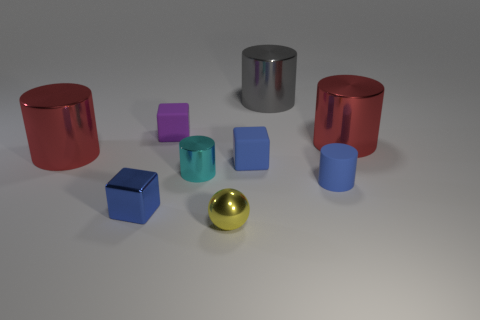Subtract all cyan metal cylinders. How many cylinders are left? 4 Add 1 cyan metal cylinders. How many objects exist? 10 Subtract 4 cylinders. How many cylinders are left? 1 Subtract all gray cylinders. How many cylinders are left? 4 Subtract all blocks. How many objects are left? 6 Subtract all brown blocks. How many blue cylinders are left? 1 Subtract all big blue metal things. Subtract all small blocks. How many objects are left? 6 Add 3 red shiny cylinders. How many red shiny cylinders are left? 5 Add 3 large gray shiny cylinders. How many large gray shiny cylinders exist? 4 Subtract 0 gray blocks. How many objects are left? 9 